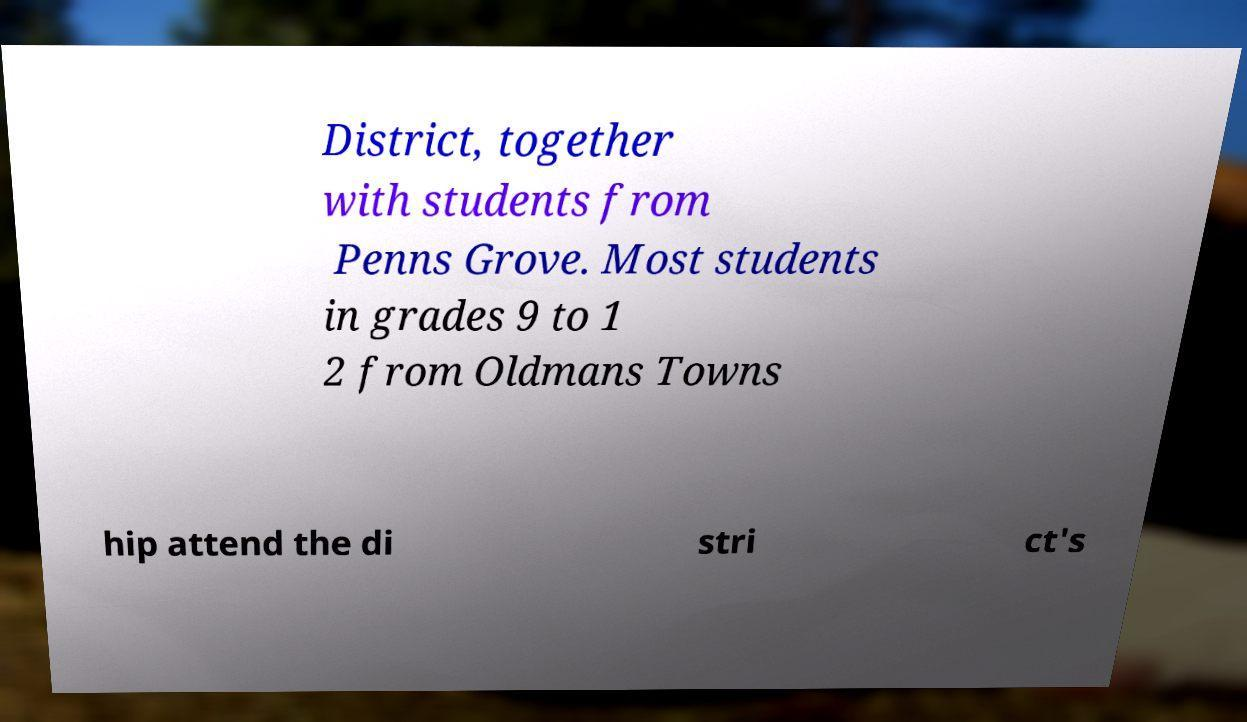Can you read and provide the text displayed in the image?This photo seems to have some interesting text. Can you extract and type it out for me? District, together with students from Penns Grove. Most students in grades 9 to 1 2 from Oldmans Towns hip attend the di stri ct's 